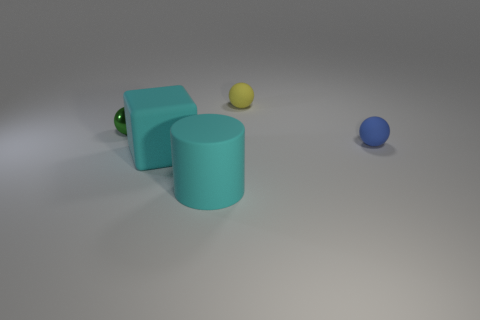Is the large cylinder the same color as the large block?
Keep it short and to the point. Yes. There is a matte object in front of the big block; is it the same color as the matte object on the left side of the big cylinder?
Make the answer very short. Yes. How many objects are either green shiny spheres or cylinders?
Make the answer very short. 2. What is the material of the small object that is in front of the ball that is to the left of the small yellow rubber thing?
Keep it short and to the point. Rubber. What number of large cyan rubber things are the same shape as the metal object?
Provide a succinct answer. 0. Is there a small matte cylinder that has the same color as the large block?
Provide a succinct answer. No. How many things are tiny rubber things right of the small yellow matte sphere or big objects that are to the right of the cyan matte block?
Offer a terse response. 2. Are there any small blue spheres that are left of the small rubber object that is behind the green metallic thing?
Your answer should be very brief. No. What is the shape of the matte thing that is the same size as the block?
Your answer should be compact. Cylinder. What number of objects are either things behind the green thing or rubber blocks?
Ensure brevity in your answer.  2. 